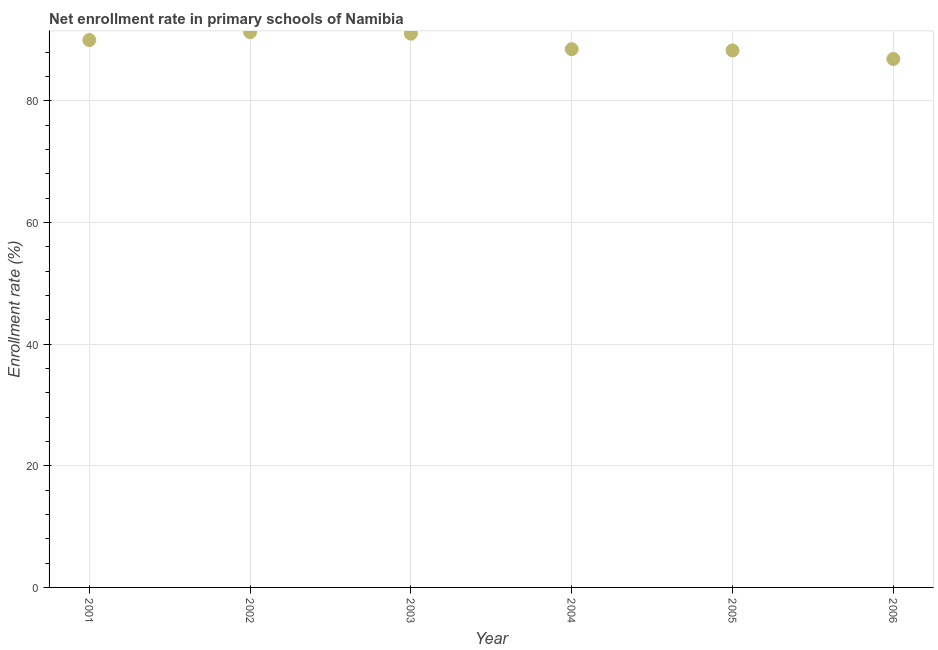What is the net enrollment rate in primary schools in 2001?
Make the answer very short. 89.97. Across all years, what is the maximum net enrollment rate in primary schools?
Make the answer very short. 91.26. Across all years, what is the minimum net enrollment rate in primary schools?
Provide a short and direct response. 86.86. What is the sum of the net enrollment rate in primary schools?
Make the answer very short. 535.84. What is the difference between the net enrollment rate in primary schools in 2003 and 2006?
Your answer should be compact. 4.16. What is the average net enrollment rate in primary schools per year?
Your answer should be compact. 89.31. What is the median net enrollment rate in primary schools?
Ensure brevity in your answer.  89.22. In how many years, is the net enrollment rate in primary schools greater than 60 %?
Keep it short and to the point. 6. What is the ratio of the net enrollment rate in primary schools in 2002 to that in 2003?
Your answer should be very brief. 1. Is the difference between the net enrollment rate in primary schools in 2003 and 2004 greater than the difference between any two years?
Ensure brevity in your answer.  No. What is the difference between the highest and the second highest net enrollment rate in primary schools?
Give a very brief answer. 0.25. Is the sum of the net enrollment rate in primary schools in 2002 and 2005 greater than the maximum net enrollment rate in primary schools across all years?
Give a very brief answer. Yes. What is the difference between the highest and the lowest net enrollment rate in primary schools?
Provide a short and direct response. 4.41. In how many years, is the net enrollment rate in primary schools greater than the average net enrollment rate in primary schools taken over all years?
Give a very brief answer. 3. Does the net enrollment rate in primary schools monotonically increase over the years?
Offer a very short reply. No. How many years are there in the graph?
Provide a short and direct response. 6. Does the graph contain grids?
Offer a terse response. Yes. What is the title of the graph?
Your answer should be compact. Net enrollment rate in primary schools of Namibia. What is the label or title of the Y-axis?
Your answer should be very brief. Enrollment rate (%). What is the Enrollment rate (%) in 2001?
Ensure brevity in your answer.  89.97. What is the Enrollment rate (%) in 2002?
Ensure brevity in your answer.  91.26. What is the Enrollment rate (%) in 2003?
Provide a short and direct response. 91.02. What is the Enrollment rate (%) in 2004?
Provide a short and direct response. 88.47. What is the Enrollment rate (%) in 2005?
Your answer should be very brief. 88.27. What is the Enrollment rate (%) in 2006?
Keep it short and to the point. 86.86. What is the difference between the Enrollment rate (%) in 2001 and 2002?
Offer a very short reply. -1.29. What is the difference between the Enrollment rate (%) in 2001 and 2003?
Make the answer very short. -1.05. What is the difference between the Enrollment rate (%) in 2001 and 2004?
Keep it short and to the point. 1.5. What is the difference between the Enrollment rate (%) in 2001 and 2005?
Give a very brief answer. 1.7. What is the difference between the Enrollment rate (%) in 2001 and 2006?
Offer a very short reply. 3.12. What is the difference between the Enrollment rate (%) in 2002 and 2003?
Provide a succinct answer. 0.25. What is the difference between the Enrollment rate (%) in 2002 and 2004?
Offer a very short reply. 2.8. What is the difference between the Enrollment rate (%) in 2002 and 2005?
Offer a very short reply. 3. What is the difference between the Enrollment rate (%) in 2002 and 2006?
Offer a very short reply. 4.41. What is the difference between the Enrollment rate (%) in 2003 and 2004?
Your response must be concise. 2.55. What is the difference between the Enrollment rate (%) in 2003 and 2005?
Offer a terse response. 2.75. What is the difference between the Enrollment rate (%) in 2003 and 2006?
Keep it short and to the point. 4.16. What is the difference between the Enrollment rate (%) in 2004 and 2005?
Your response must be concise. 0.2. What is the difference between the Enrollment rate (%) in 2004 and 2006?
Keep it short and to the point. 1.61. What is the difference between the Enrollment rate (%) in 2005 and 2006?
Your answer should be very brief. 1.41. What is the ratio of the Enrollment rate (%) in 2001 to that in 2003?
Give a very brief answer. 0.99. What is the ratio of the Enrollment rate (%) in 2001 to that in 2006?
Your answer should be very brief. 1.04. What is the ratio of the Enrollment rate (%) in 2002 to that in 2003?
Your answer should be compact. 1. What is the ratio of the Enrollment rate (%) in 2002 to that in 2004?
Make the answer very short. 1.03. What is the ratio of the Enrollment rate (%) in 2002 to that in 2005?
Your response must be concise. 1.03. What is the ratio of the Enrollment rate (%) in 2002 to that in 2006?
Ensure brevity in your answer.  1.05. What is the ratio of the Enrollment rate (%) in 2003 to that in 2005?
Provide a succinct answer. 1.03. What is the ratio of the Enrollment rate (%) in 2003 to that in 2006?
Offer a very short reply. 1.05. 